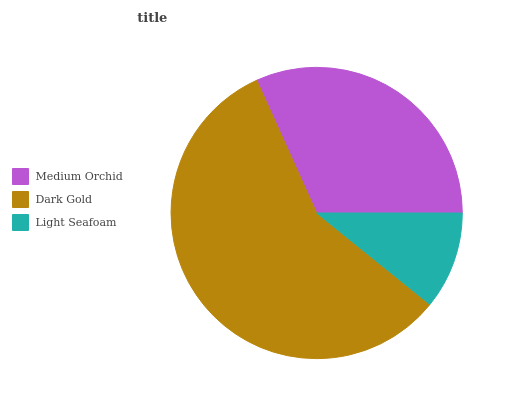Is Light Seafoam the minimum?
Answer yes or no. Yes. Is Dark Gold the maximum?
Answer yes or no. Yes. Is Dark Gold the minimum?
Answer yes or no. No. Is Light Seafoam the maximum?
Answer yes or no. No. Is Dark Gold greater than Light Seafoam?
Answer yes or no. Yes. Is Light Seafoam less than Dark Gold?
Answer yes or no. Yes. Is Light Seafoam greater than Dark Gold?
Answer yes or no. No. Is Dark Gold less than Light Seafoam?
Answer yes or no. No. Is Medium Orchid the high median?
Answer yes or no. Yes. Is Medium Orchid the low median?
Answer yes or no. Yes. Is Light Seafoam the high median?
Answer yes or no. No. Is Light Seafoam the low median?
Answer yes or no. No. 